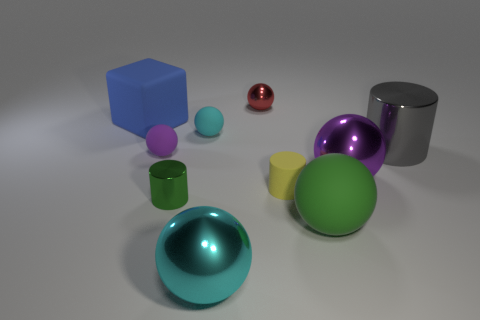Are the tiny purple thing and the large purple object made of the same material?
Your answer should be very brief. No. There is a rubber sphere left of the tiny matte object behind the big gray cylinder; what number of large gray metal cylinders are in front of it?
Your answer should be compact. 0. Is there a ball that has the same material as the tiny purple thing?
Your response must be concise. Yes. The sphere that is the same color as the tiny shiny cylinder is what size?
Give a very brief answer. Large. Is the number of rubber cylinders less than the number of tiny red cylinders?
Give a very brief answer. No. Does the large rubber thing in front of the small green thing have the same color as the tiny shiny cylinder?
Give a very brief answer. Yes. What is the purple thing on the right side of the metal object behind the cyan object that is behind the gray object made of?
Your answer should be very brief. Metal. Are there any tiny matte things of the same color as the tiny metal ball?
Your response must be concise. No. Is the number of green metallic things on the left side of the small green cylinder less than the number of cyan metal spheres?
Offer a very short reply. Yes. Is the size of the ball that is behind the blue matte thing the same as the purple metallic object?
Your answer should be very brief. No. 